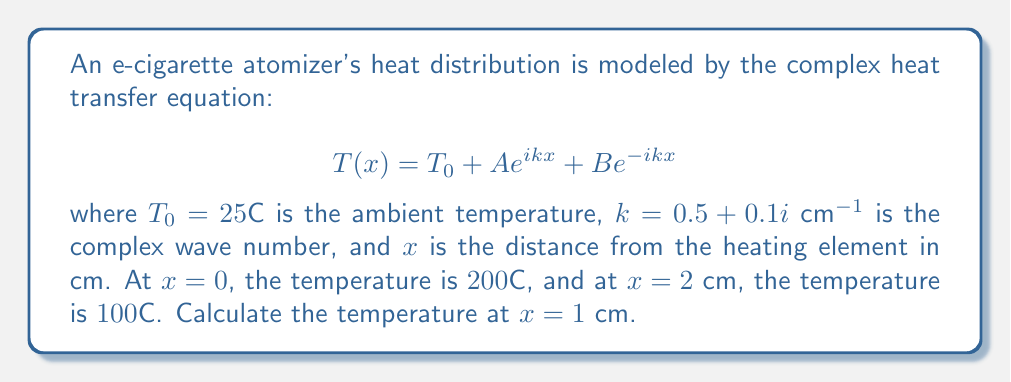Solve this math problem. 1) First, we need to find the constants A and B using the given boundary conditions:

   At $x = 0$: $T(0) = 200 = 25 + A + B$
   At $x = 2$: $T(2) = 100 = 25 + A e^{2ik} + B e^{-2ik}$

2) Simplify the second equation:
   $75 = A e^{2ik} + B e^{-2ik}$

3) Calculate $e^{2ik}$:
   $e^{2ik} = e^{2(0.5 + 0.1i)} = e^1 (\cos 0.2 + i \sin 0.2) \approx 2.5758 + 0.5207i$

4) Substitute this into the equations:
   $175 = A + B$
   $75 = A(2.5758 + 0.5207i) + B(0.3679 - 0.0743i)$

5) Solve this system of equations:
   $A \approx 114.7 - 23.2i$
   $B \approx 60.3 + 23.2i$

6) Now, calculate the temperature at $x = 1$ cm:
   $T(1) = 25 + A e^{ik} + B e^{-ik}$

7) Calculate $e^{ik}$ and $e^{-ik}$:
   $e^{ik} = e^{0.5 + 0.1i} \approx 1.6054 + 0.1622i$
   $e^{-ik} = e^{-0.5 - 0.1i} \approx 0.6065 - 0.0613i$

8) Substitute and calculate:
   $T(1) = 25 + (114.7 - 23.2i)(1.6054 + 0.1622i) + (60.3 + 23.2i)(0.6065 - 0.0613i)$
   $T(1) \approx 25 + 180.5 + 32.7 = 238.2°C$
Answer: $238.2°C$ 